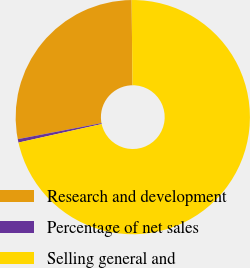Convert chart. <chart><loc_0><loc_0><loc_500><loc_500><pie_chart><fcel>Research and development<fcel>Percentage of net sales<fcel>Selling general and<nl><fcel>27.85%<fcel>0.47%<fcel>71.67%<nl></chart> 